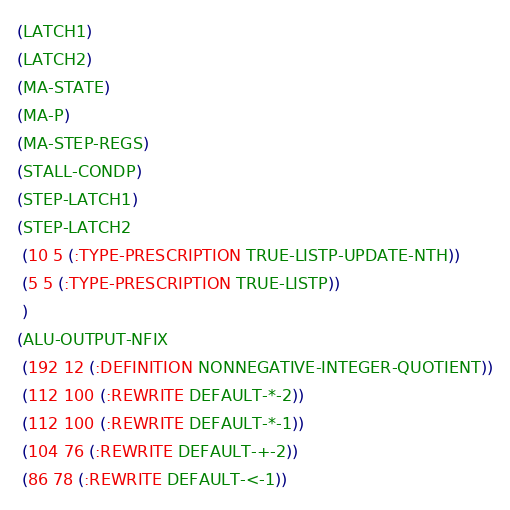Convert code to text. <code><loc_0><loc_0><loc_500><loc_500><_Lisp_>(LATCH1)
(LATCH2)
(MA-STATE)
(MA-P)
(MA-STEP-REGS)
(STALL-CONDP)
(STEP-LATCH1)
(STEP-LATCH2
 (10 5 (:TYPE-PRESCRIPTION TRUE-LISTP-UPDATE-NTH))
 (5 5 (:TYPE-PRESCRIPTION TRUE-LISTP))
 )
(ALU-OUTPUT-NFIX
 (192 12 (:DEFINITION NONNEGATIVE-INTEGER-QUOTIENT))
 (112 100 (:REWRITE DEFAULT-*-2))
 (112 100 (:REWRITE DEFAULT-*-1))
 (104 76 (:REWRITE DEFAULT-+-2))
 (86 78 (:REWRITE DEFAULT-<-1))</code> 